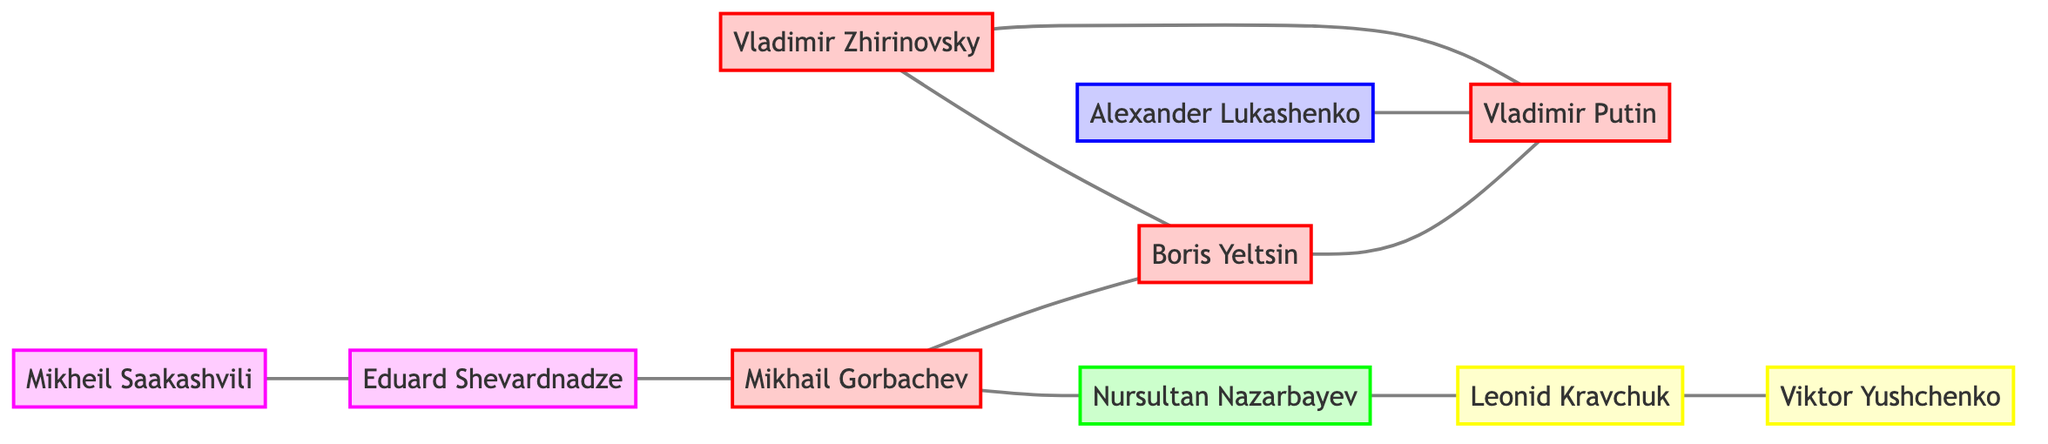How many nodes are in the graph? The graph contains a total of 10 nodes representing key political figures in post-Soviet democratization.
Answer: 10 Who is connected to Vladimir Putin? Vladimir Putin has connections with Boris Yeltsin, Alexander Lukashenko, and Mikhail Gorbachev, as indicated by the edges leading to these nodes.
Answer: Boris Yeltsin, Alexander Lukashenko, Mikhail Gorbachev Which figure has a direct connection to Eduard Shevardnadze? Eduard Shevardnadze is directly connected to Mikheil Saakashvili and Mikhail Gorbachev based on the edges leading from his node.
Answer: Mikheil Saakashvili, Mikhail Gorbachev What is the total number of edges in the graph? The graph has a total of 10 edges, which represent the relationships between the political figures indicated in the diagram.
Answer: 10 How many figures from Ukraine are represented in the graph? There are three figures from Ukraine in the graph: Leonid Kravchuk, Viktor Yushchenko, and Eduard Shevardnadze, as indicated by the respective nodes for these individuals.
Answer: 3 Which political figure has the most connections to others in the graph? Analyzing the connections, Boris Yeltsin has three edges leading to him, making him the figure with the most direct connections.
Answer: Boris Yeltsin Is Mikhail Gorbachev connected to any leader from Belarus? Mikhail Gorbachev has no direct connections to Alexander Lukashenko, the only leader from Belarus in the graph, as indicated by the absence of an edge connecting these two nodes.
Answer: No Determine the path from Nursultan Nazarbayev to Viktor Yushchenko. The path is as follows: Nursultan Nazarbayev is connected to Leonid Kravchuk, who is then connected to Viktor Yushchenko. Thus, the route is Nursultan Nazarbayev to Leonid Kravchuk to Viktor Yushchenko.
Answer: Nursultan Nazarbayev, Leonid Kravchuk, Viktor Yushchenko What is the relationship between Mikhail Gorbachev and Boris Yeltsin? Mikhail Gorbachev and Boris Yeltsin are directly connected, indicated by the edge that links these two nodes.
Answer: Directly connected 